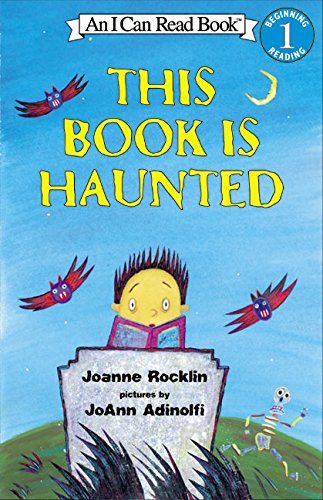What type of book is this? This is a children's book, specifically a beginning reader book from the 'I Can Read' series, intended to help develop early reading skills with engaging stories and colorful illustrations. 